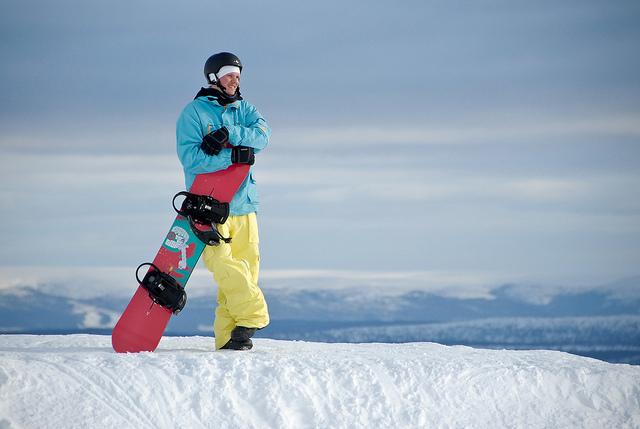Is this person relaxed?
Concise answer only. Yes. Is the snowboarder down in a valley?
Give a very brief answer. No. What is the woman leaning on?
Write a very short answer. Snowboard. 